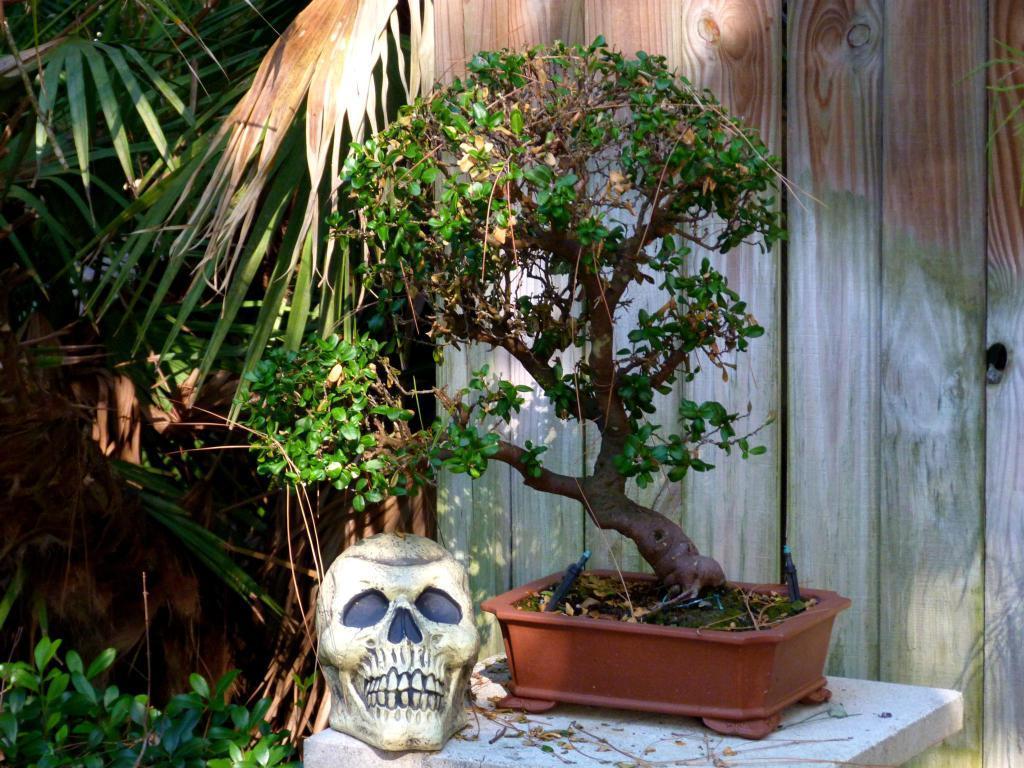Could you give a brief overview of what you see in this image? In this image on a stand there is a plant pot. There is a skull like structure. In the background there is wall and trees. 